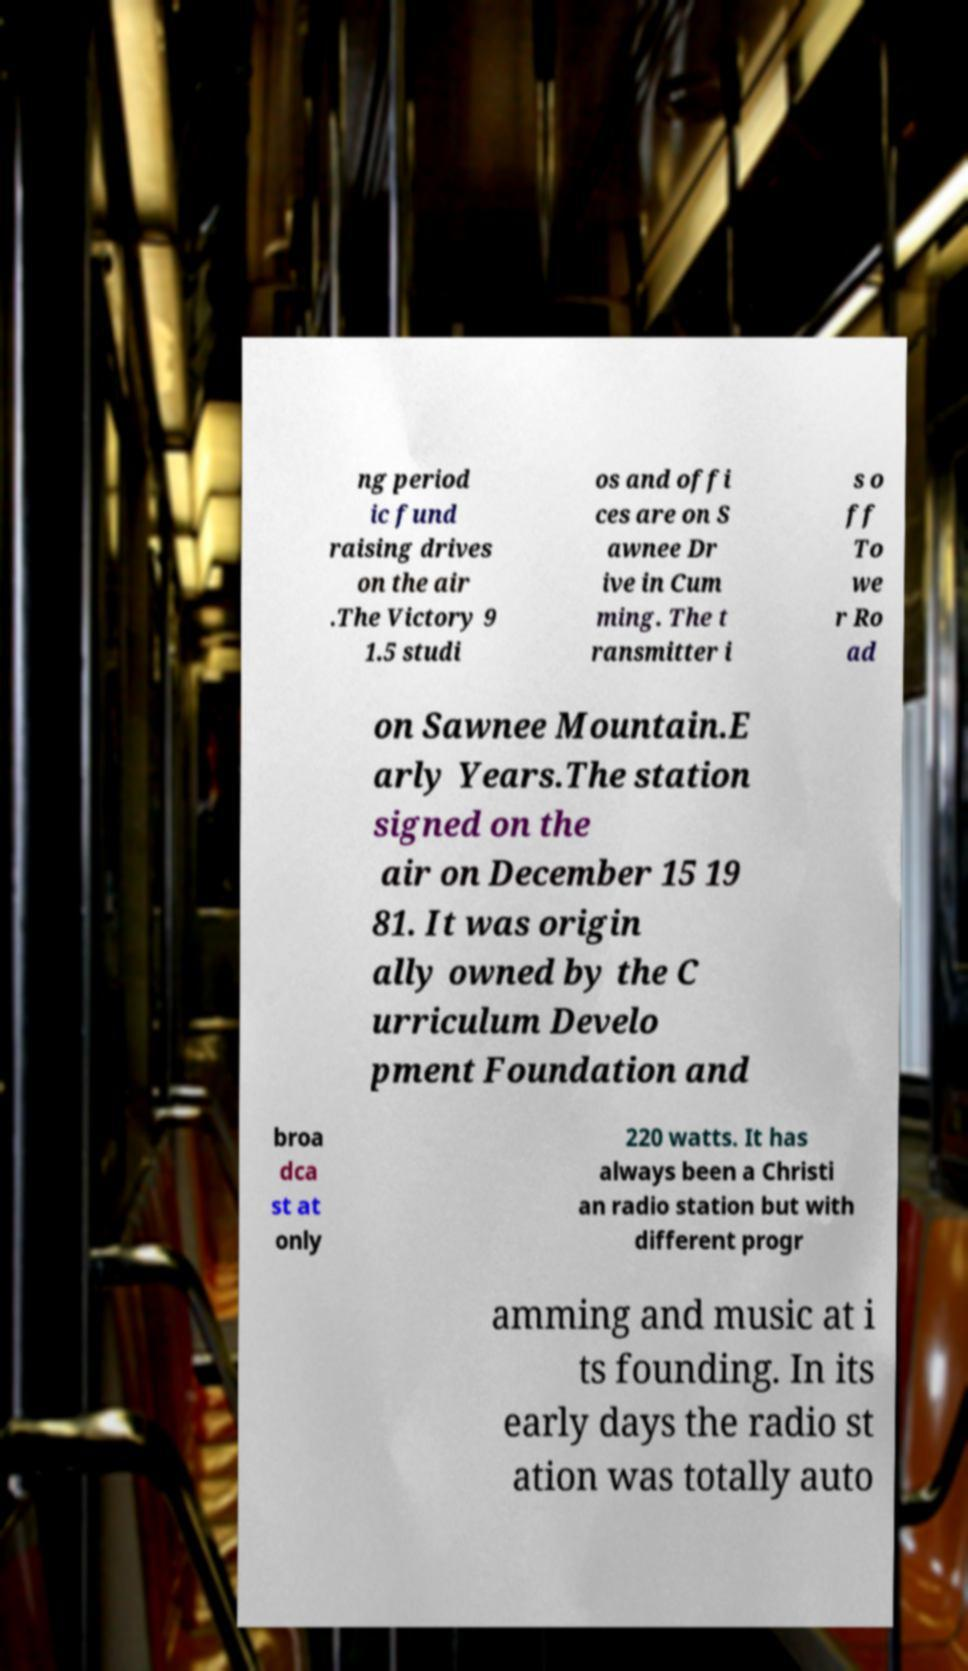Could you assist in decoding the text presented in this image and type it out clearly? ng period ic fund raising drives on the air .The Victory 9 1.5 studi os and offi ces are on S awnee Dr ive in Cum ming. The t ransmitter i s o ff To we r Ro ad on Sawnee Mountain.E arly Years.The station signed on the air on December 15 19 81. It was origin ally owned by the C urriculum Develo pment Foundation and broa dca st at only 220 watts. It has always been a Christi an radio station but with different progr amming and music at i ts founding. In its early days the radio st ation was totally auto 